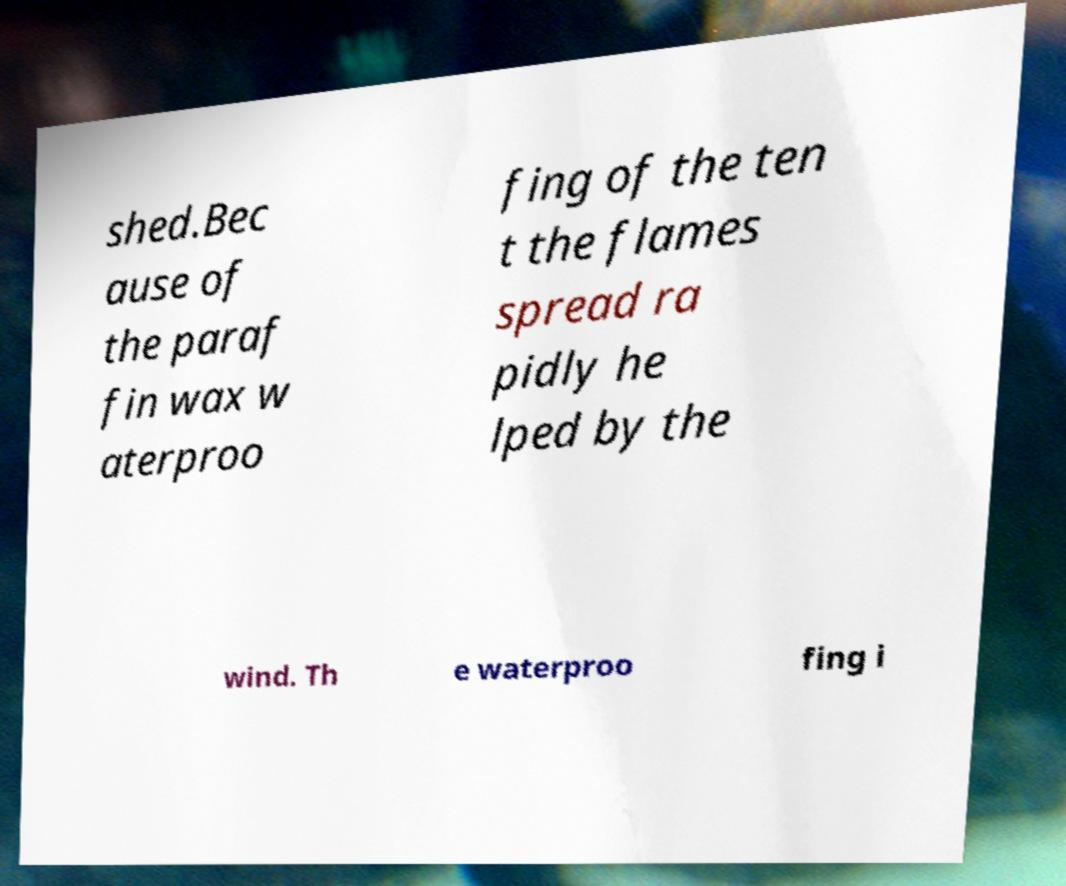For documentation purposes, I need the text within this image transcribed. Could you provide that? shed.Bec ause of the paraf fin wax w aterproo fing of the ten t the flames spread ra pidly he lped by the wind. Th e waterproo fing i 